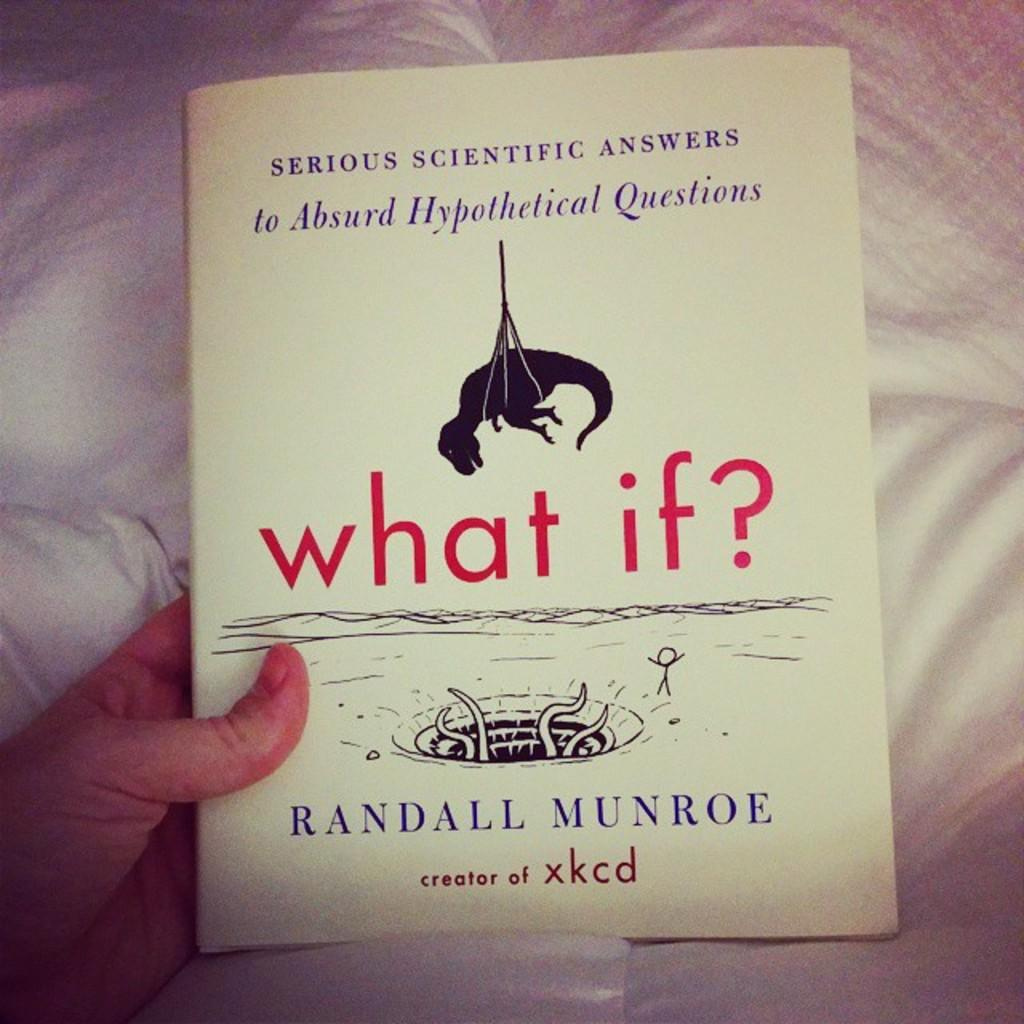<image>
Describe the image concisely. The book called What If by Randall Munroe is held by a person under a blanket. 